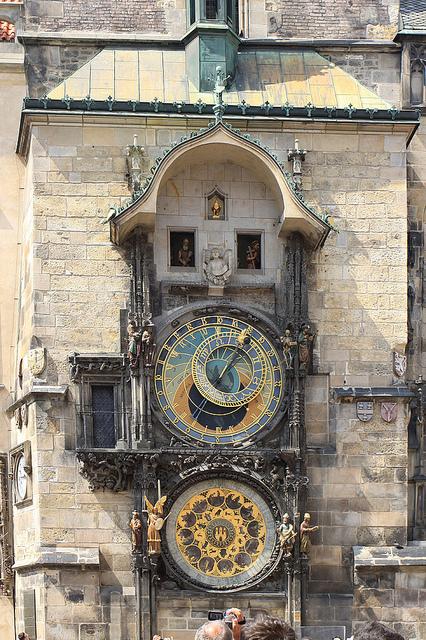Is the weather rainy?
Keep it brief. No. Are these clocks?
Quick response, please. Yes. What is this building made of?
Short answer required. Stone. 